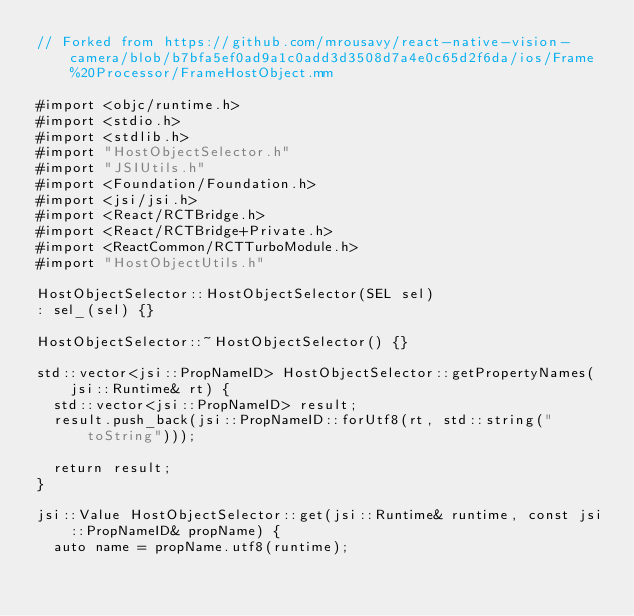<code> <loc_0><loc_0><loc_500><loc_500><_ObjectiveC_>// Forked from https://github.com/mrousavy/react-native-vision-camera/blob/b7bfa5ef0ad9a1c0add3d3508d7a4e0c65d2f6da/ios/Frame%20Processor/FrameHostObject.mm

#import <objc/runtime.h>
#import <stdio.h>
#import <stdlib.h>
#import "HostObjectSelector.h"
#import "JSIUtils.h"
#import <Foundation/Foundation.h>
#import <jsi/jsi.h>
#import <React/RCTBridge.h>
#import <React/RCTBridge+Private.h>
#import <ReactCommon/RCTTurboModule.h>
#import "HostObjectUtils.h"

HostObjectSelector::HostObjectSelector(SEL sel)
: sel_(sel) {}

HostObjectSelector::~HostObjectSelector() {}

std::vector<jsi::PropNameID> HostObjectSelector::getPropertyNames(jsi::Runtime& rt) {
  std::vector<jsi::PropNameID> result;
  result.push_back(jsi::PropNameID::forUtf8(rt, std::string("toString")));
  
  return result;
}

jsi::Value HostObjectSelector::get(jsi::Runtime& runtime, const jsi::PropNameID& propName) {
  auto name = propName.utf8(runtime);</code> 